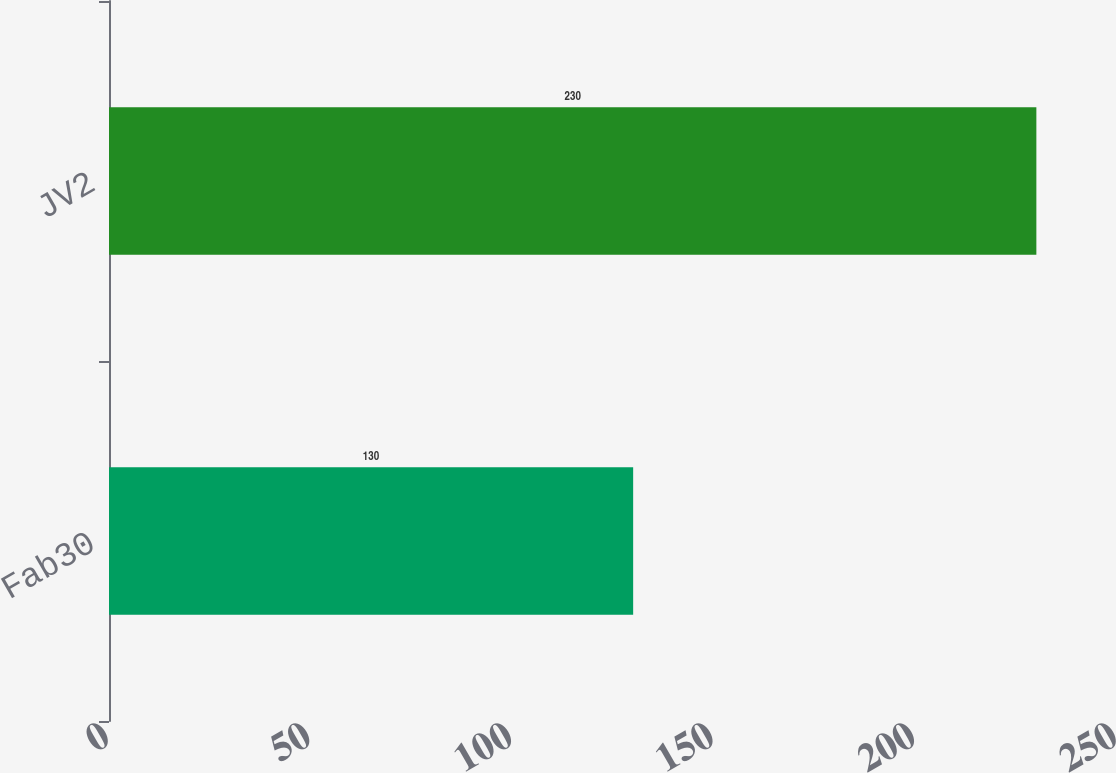Convert chart to OTSL. <chart><loc_0><loc_0><loc_500><loc_500><bar_chart><fcel>Fab30<fcel>JV2<nl><fcel>130<fcel>230<nl></chart> 